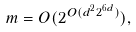<formula> <loc_0><loc_0><loc_500><loc_500>m = O ( 2 ^ { O ( d ^ { 2 } 2 ^ { 6 d } ) } ) ,</formula> 